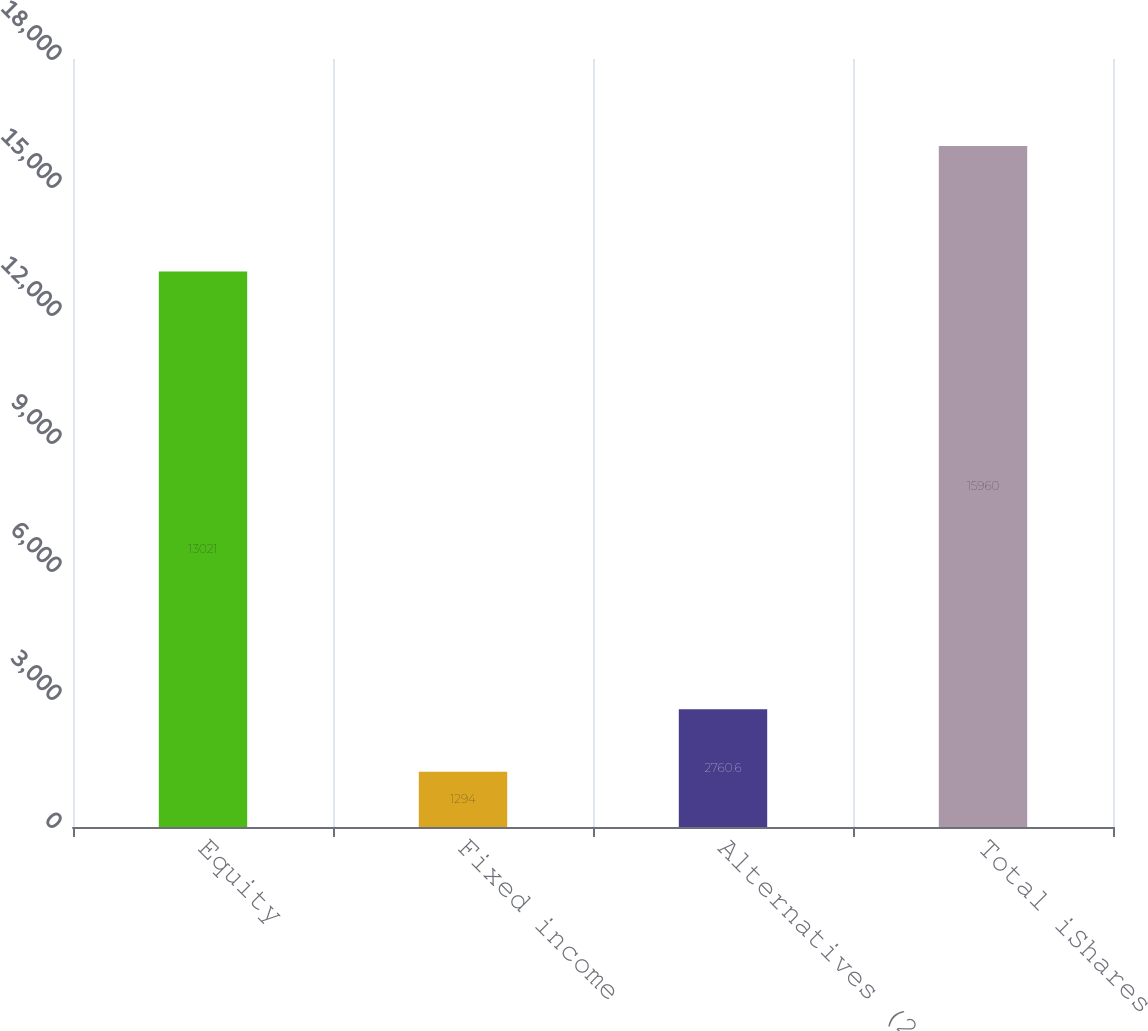Convert chart. <chart><loc_0><loc_0><loc_500><loc_500><bar_chart><fcel>Equity<fcel>Fixed income<fcel>Alternatives (2)<fcel>Total iShares<nl><fcel>13021<fcel>1294<fcel>2760.6<fcel>15960<nl></chart> 